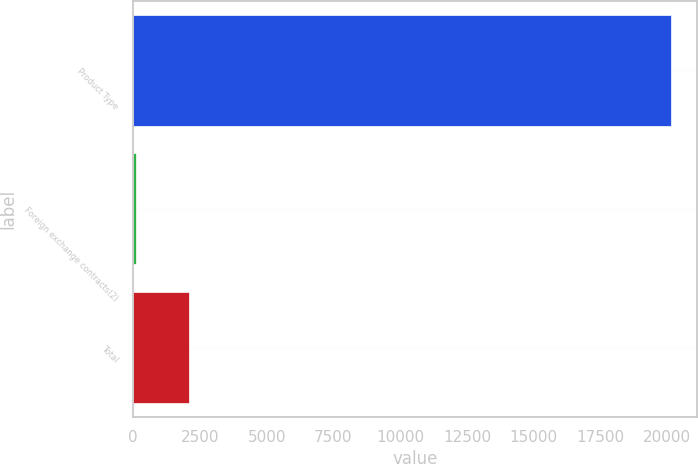Convert chart. <chart><loc_0><loc_0><loc_500><loc_500><bar_chart><fcel>Product Type<fcel>Foreign exchange contracts(2)<fcel>Total<nl><fcel>20121<fcel>102<fcel>2103.9<nl></chart> 